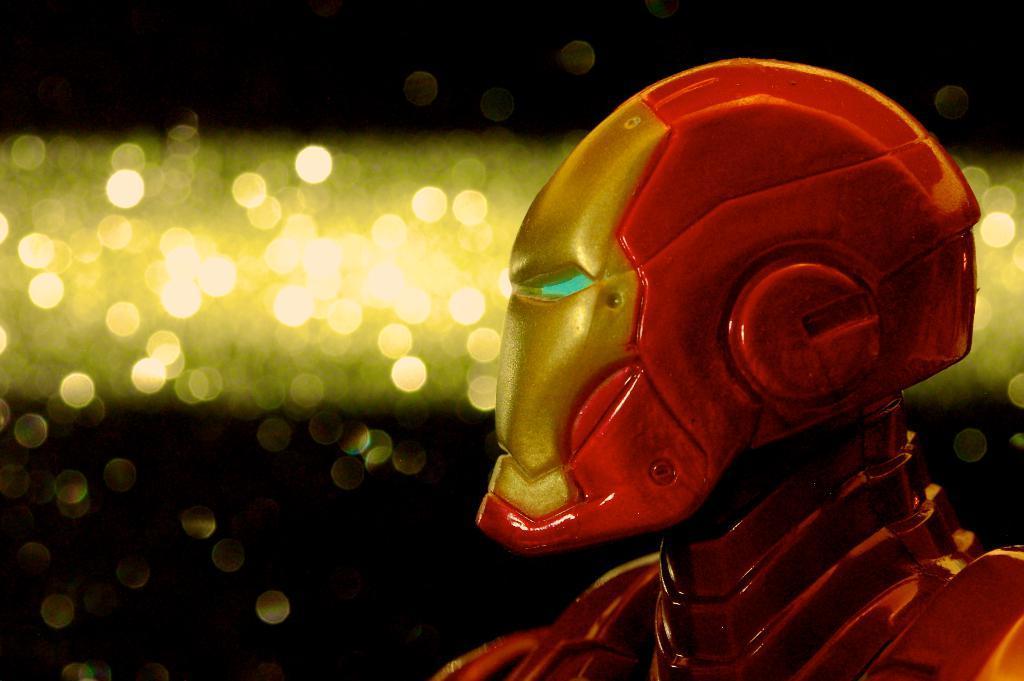How would you summarize this image in a sentence or two? In this picture we can see a robot, lights and in the background it is dark. 